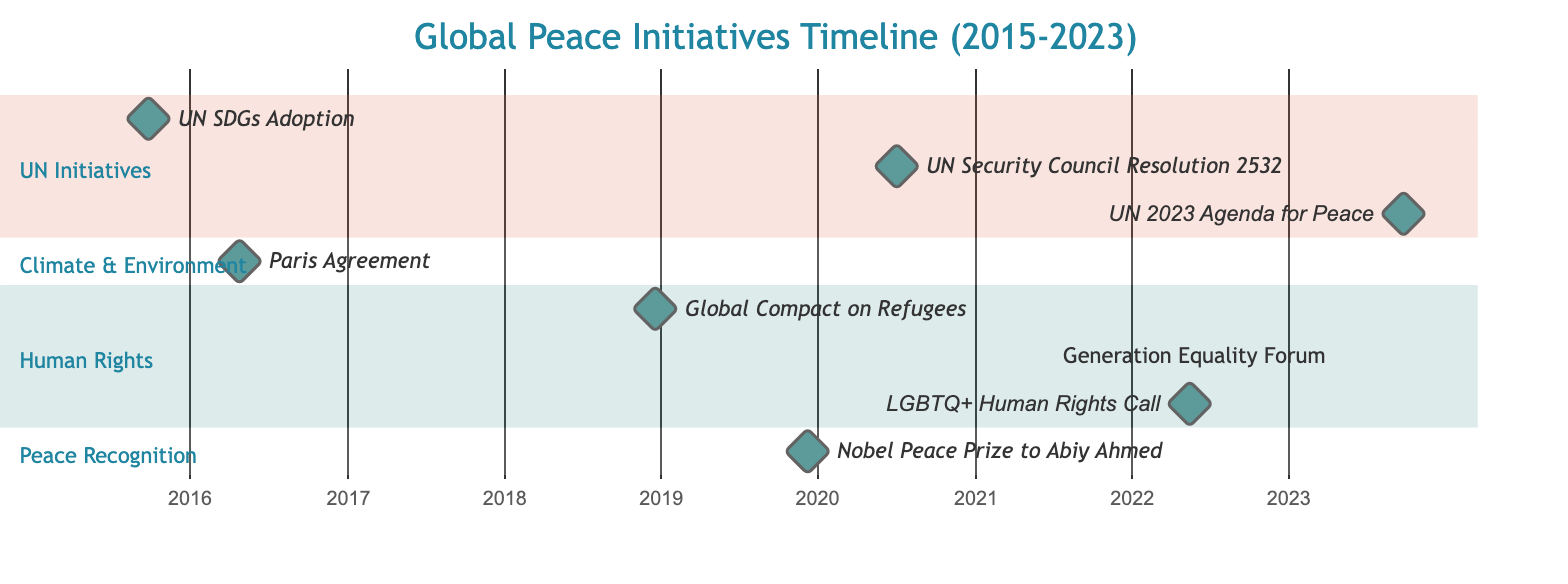What is the earliest initiative shown in the diagram? The earliest initiative is the "United Nations Sustainable Development Goals (SDGs) Adoption," which is represented by the milestone at the date 2015-09-25. It's the first item listed in the UN Initiatives section, and its date is the earliest compared to other entries.
Answer: United Nations Sustainable Development Goals (SDGs) Adoption How many peace initiatives are represented in the diagram? The diagram features a total of eight initiatives. By counting each distinct entry in the sections provided, we can affirm that there are eight milestones and events listed.
Answer: 8 Which initiative is directly related to climate change? The initiative related to climate change is the "Paris Agreement on Climate Change," which is noted as a milestone in the Climate & Environment section. This entry specifically aims at reducing carbon emissions.
Answer: Paris Agreement on Climate Change What year was the Nobel Peace Prize awarded to Abiy Ahmed? The Nobel Peace Prize was awarded to Abiy Ahmed on December 10, 2019, as shown in the Peace Recognition section where this specific milestone is marked with the respective date.
Answer: 2019 Which initiative spans more than one day? The initiative that spans more than one day is the "Generation Equality Forum," which lasts for two days from July 1 to July 2, 2021, as indicated by the duration noted in the diagram.
Answer: Generation Equality Forum What do the UN SDGs aim to address? The UN Sustainable Development Goals (SDGs) aim to tackle poverty and protect the planet, as stated in the description alongside the milestone in the diagram. This initiative encompasses a broad spectrum of societal needs including peace and prosperity.
Answer: Tackle poverty and protect the planet What is the purpose of the UN Security Council Resolution 2532? The purpose of the UN Security Council Resolution 2532, marked on July 1, 2020, is to call for a global ceasefire amid the COVID-19 pandemic to allow humanitarian aid access. This highlights efforts during the crisis to promote peace.
Answer: Global ceasefire amid COVID-19 How long after the Paris Agreement was the Global Compact on Refugees initiated? The Global Compact on Refugees was initiated on December 17, 2018, which is about 2 years and 7 months after the Paris Agreement was adopted on April 22, 2016. To find the difference, we calculate the number of months between these two milestones.
Answer: 2 years and 7 months 